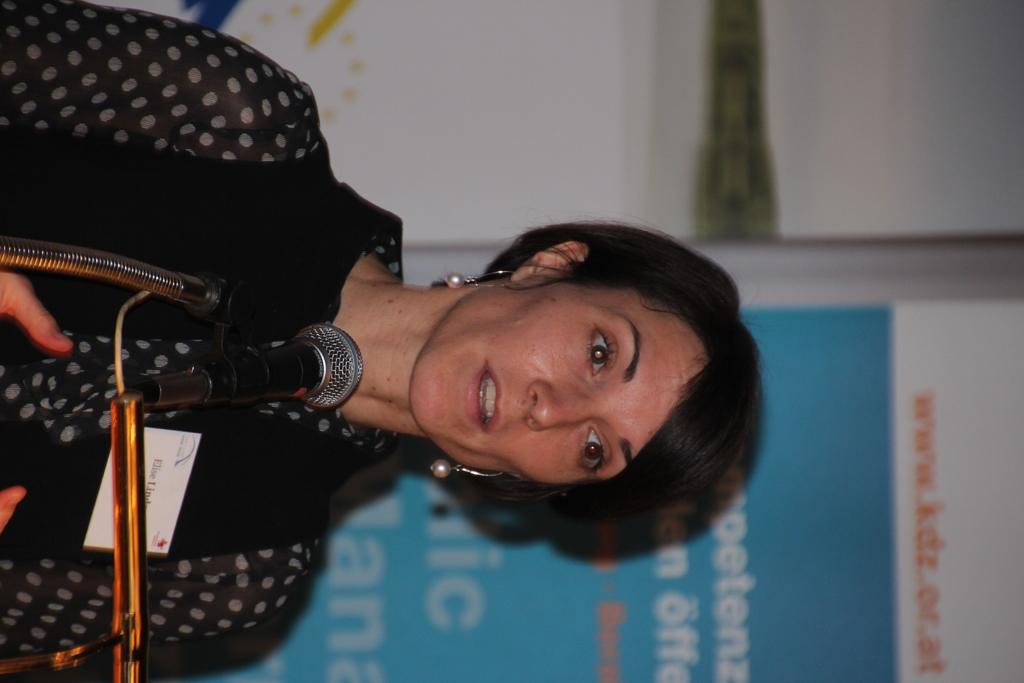Who is the main subject in the image? There is a lady in the center of the image. What is the lady wearing? The lady is wearing a badge. What objects can be seen in the image related to music? There are mic stands in the image. What can be seen on the wall in the background of the image? There is a board on the wall in the background of the image. What type of crime is being committed in the image? There is no crime being committed in the image; it features a lady wearing a badge and mic stands. Can you see a kitty playing with the mic stands in the image? There is no kitty present in the image; it only features a lady, mic stands, and a board on the wall. 